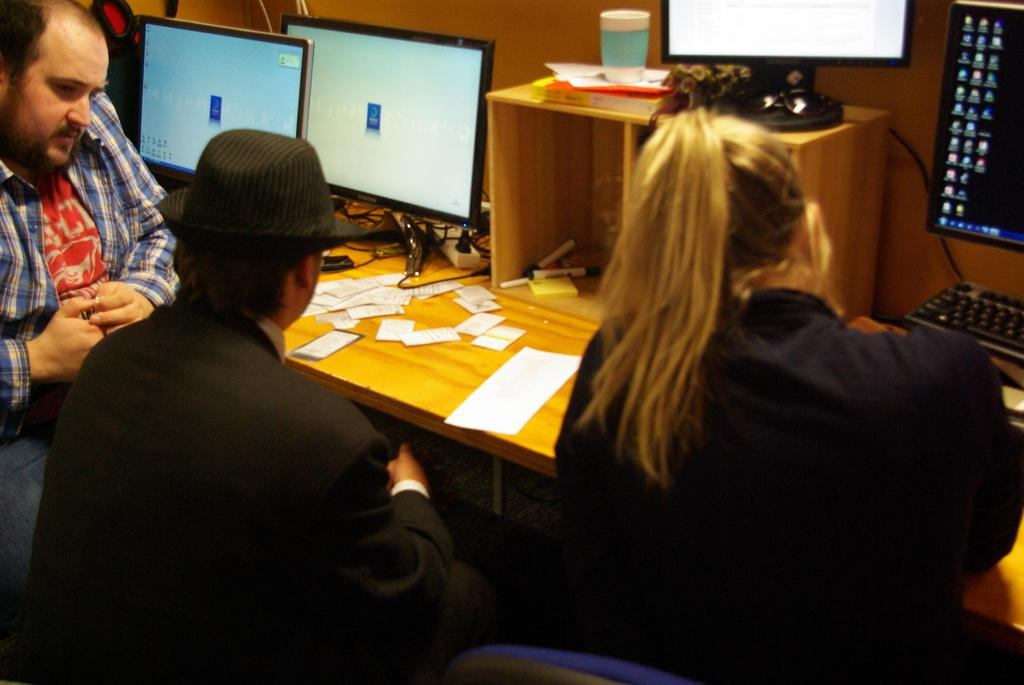What are the people in the image doing? The people in the image are sitting on chairs. What type of electronic devices are present in the image? There are monitors in the image. What type of writing or marking tool is visible in the image? There is a marker in the image. What type of beverage container is present in the image? There is a coffee cup in the image. What type of power supply device is present in the image? There is an extension box in the image. What type of brick is being used to hold the coffee cup in the image? There is no brick present in the image; the coffee cup is resting on a surface. What type of fowl can be seen interacting with the paper slips in the image? There is no fowl present in the image; only people, chairs, monitors, paper slips, keyboards, a marker, a coffee cup, and an extension box are visible. 